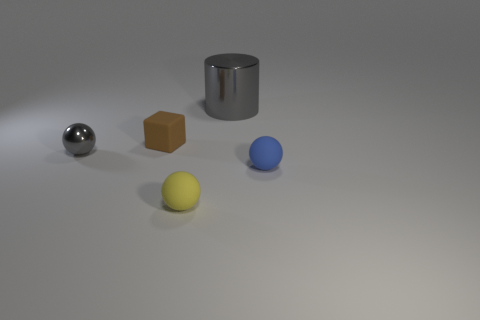Subtract all yellow matte balls. How many balls are left? 2 Add 5 large cyan rubber cylinders. How many objects exist? 10 Subtract all blocks. How many objects are left? 4 Subtract all blue rubber balls. Subtract all tiny brown objects. How many objects are left? 3 Add 2 small gray things. How many small gray things are left? 3 Add 2 small brown rubber balls. How many small brown rubber balls exist? 2 Subtract 0 brown cylinders. How many objects are left? 5 Subtract all brown balls. Subtract all red cylinders. How many balls are left? 3 